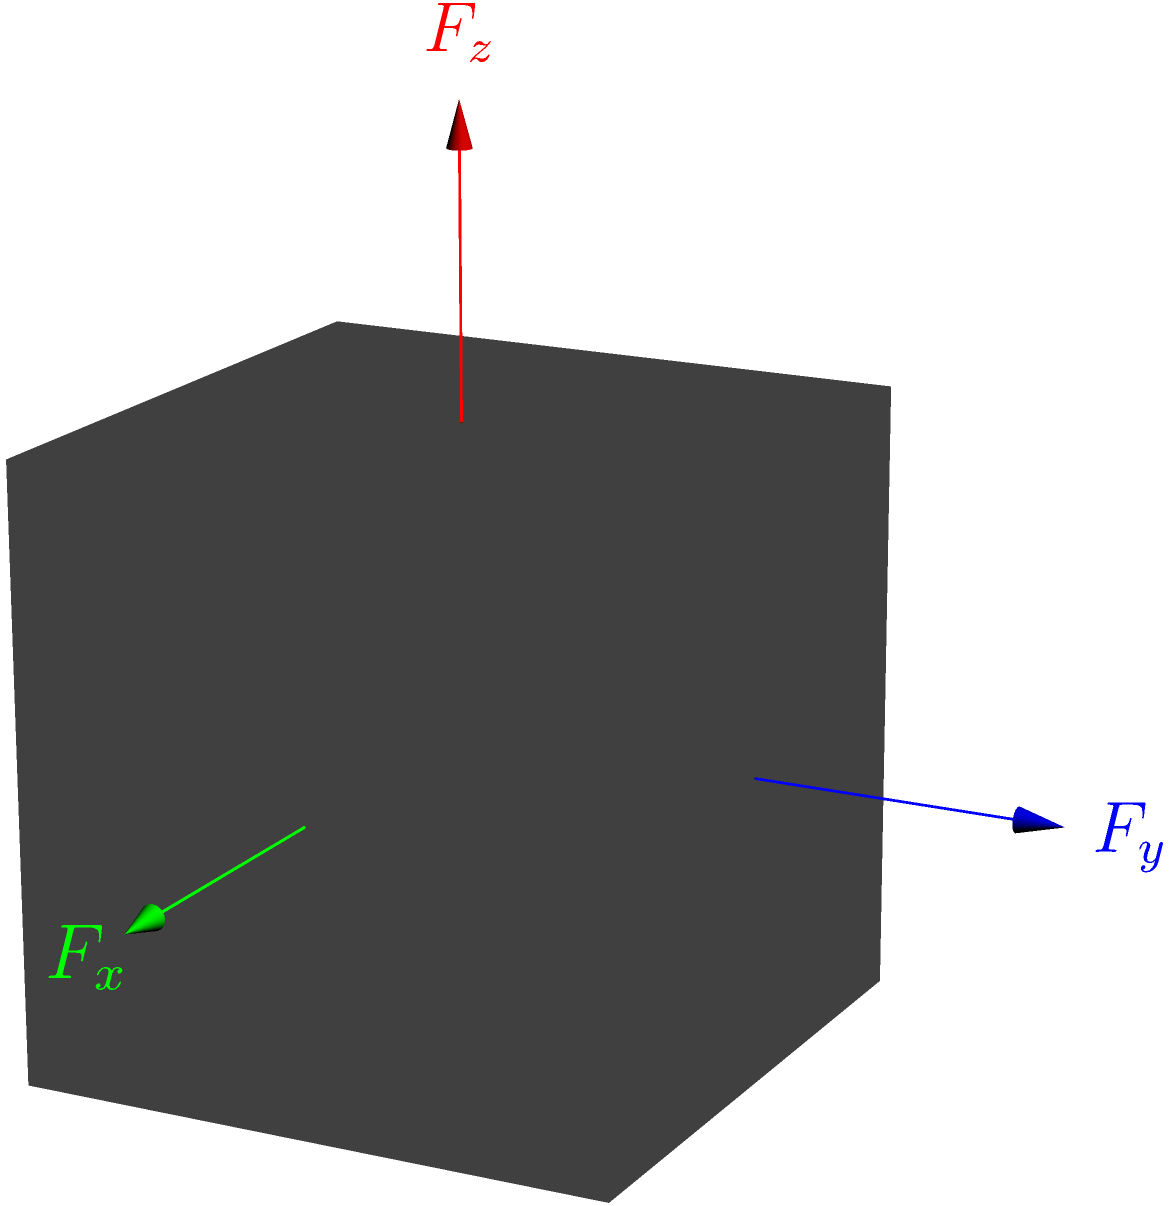A 3D printed cube with side length $a$ is subjected to three orthogonal forces $F_x$, $F_y$, and $F_z$ as shown in the diagram. If the material has a Young's modulus $E$ and Poisson's ratio $\nu$, determine the maximum von Mises stress $\sigma_{VM}$ in the cube. Assume the forces are uniformly distributed over their respective faces. To determine the maximum von Mises stress, we'll follow these steps:

1. Calculate the normal stresses in each direction:
   $\sigma_x = \frac{F_x}{a^2}$, $\sigma_y = \frac{F_y}{a^2}$, $\sigma_z = \frac{F_z}{a^2}$

2. Assume shear stresses are negligible due to uniform force distribution.

3. The von Mises stress equation for principal stresses is:
   $\sigma_{VM} = \sqrt{\frac{1}{2}[(\sigma_1 - \sigma_2)^2 + (\sigma_2 - \sigma_3)^2 + (\sigma_3 - \sigma_1)^2]}$

4. In this case, $\sigma_1 = \sigma_x$, $\sigma_2 = \sigma_y$, and $\sigma_3 = \sigma_z$

5. Substituting into the von Mises equation:
   $\sigma_{VM} = \sqrt{\frac{1}{2}[(\frac{F_x}{a^2} - \frac{F_y}{a^2})^2 + (\frac{F_y}{a^2} - \frac{F_z}{a^2})^2 + (\frac{F_z}{a^2} - \frac{F_x}{a^2})^2]}$

6. Simplifying:
   $\sigma_{VM} = \frac{1}{a^2}\sqrt{\frac{1}{2}[(F_x - F_y)^2 + (F_y - F_z)^2 + (F_z - F_x)^2]}$

This equation gives the maximum von Mises stress in the cube under the given loading conditions.
Answer: $\sigma_{VM} = \frac{1}{a^2}\sqrt{\frac{1}{2}[(F_x - F_y)^2 + (F_y - F_z)^2 + (F_z - F_x)^2]}$ 